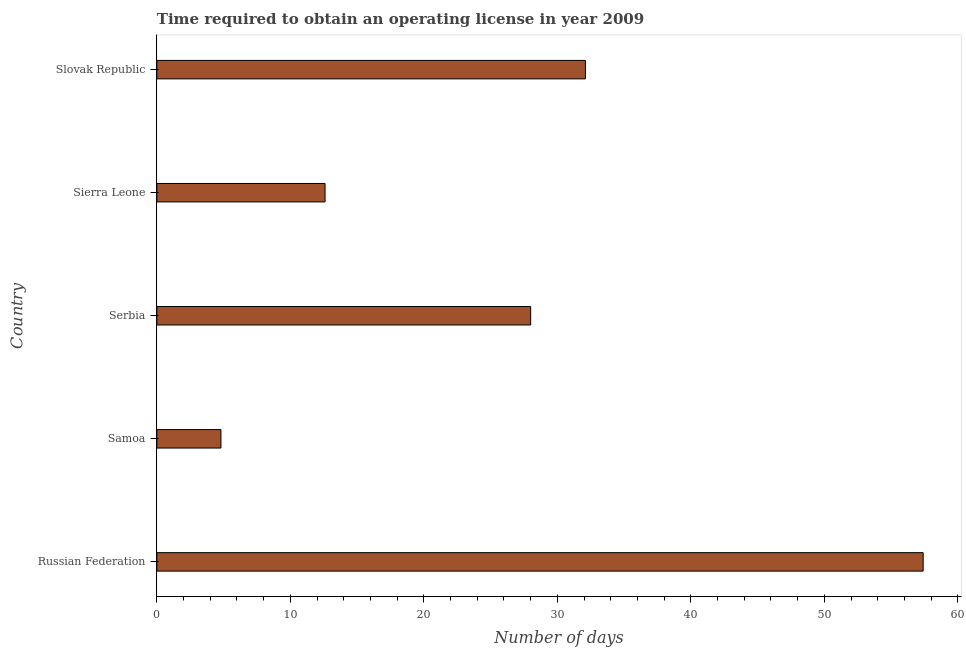Does the graph contain any zero values?
Keep it short and to the point. No. What is the title of the graph?
Keep it short and to the point. Time required to obtain an operating license in year 2009. What is the label or title of the X-axis?
Offer a terse response. Number of days. What is the label or title of the Y-axis?
Ensure brevity in your answer.  Country. What is the number of days to obtain operating license in Russian Federation?
Give a very brief answer. 57.4. Across all countries, what is the maximum number of days to obtain operating license?
Ensure brevity in your answer.  57.4. In which country was the number of days to obtain operating license maximum?
Offer a terse response. Russian Federation. In which country was the number of days to obtain operating license minimum?
Provide a succinct answer. Samoa. What is the sum of the number of days to obtain operating license?
Make the answer very short. 134.9. What is the difference between the number of days to obtain operating license in Samoa and Slovak Republic?
Offer a terse response. -27.3. What is the average number of days to obtain operating license per country?
Ensure brevity in your answer.  26.98. What is the median number of days to obtain operating license?
Offer a terse response. 28. In how many countries, is the number of days to obtain operating license greater than 48 days?
Your response must be concise. 1. What is the ratio of the number of days to obtain operating license in Serbia to that in Slovak Republic?
Keep it short and to the point. 0.87. Is the number of days to obtain operating license in Samoa less than that in Slovak Republic?
Ensure brevity in your answer.  Yes. Is the difference between the number of days to obtain operating license in Russian Federation and Sierra Leone greater than the difference between any two countries?
Offer a terse response. No. What is the difference between the highest and the second highest number of days to obtain operating license?
Ensure brevity in your answer.  25.3. What is the difference between the highest and the lowest number of days to obtain operating license?
Offer a terse response. 52.6. How many bars are there?
Provide a short and direct response. 5. Are all the bars in the graph horizontal?
Provide a succinct answer. Yes. What is the Number of days of Russian Federation?
Your answer should be very brief. 57.4. What is the Number of days in Sierra Leone?
Ensure brevity in your answer.  12.6. What is the Number of days in Slovak Republic?
Offer a terse response. 32.1. What is the difference between the Number of days in Russian Federation and Samoa?
Offer a very short reply. 52.6. What is the difference between the Number of days in Russian Federation and Serbia?
Provide a short and direct response. 29.4. What is the difference between the Number of days in Russian Federation and Sierra Leone?
Your answer should be compact. 44.8. What is the difference between the Number of days in Russian Federation and Slovak Republic?
Your answer should be compact. 25.3. What is the difference between the Number of days in Samoa and Serbia?
Your response must be concise. -23.2. What is the difference between the Number of days in Samoa and Slovak Republic?
Offer a very short reply. -27.3. What is the difference between the Number of days in Serbia and Slovak Republic?
Ensure brevity in your answer.  -4.1. What is the difference between the Number of days in Sierra Leone and Slovak Republic?
Keep it short and to the point. -19.5. What is the ratio of the Number of days in Russian Federation to that in Samoa?
Your answer should be very brief. 11.96. What is the ratio of the Number of days in Russian Federation to that in Serbia?
Provide a succinct answer. 2.05. What is the ratio of the Number of days in Russian Federation to that in Sierra Leone?
Give a very brief answer. 4.56. What is the ratio of the Number of days in Russian Federation to that in Slovak Republic?
Your answer should be very brief. 1.79. What is the ratio of the Number of days in Samoa to that in Serbia?
Make the answer very short. 0.17. What is the ratio of the Number of days in Samoa to that in Sierra Leone?
Offer a very short reply. 0.38. What is the ratio of the Number of days in Serbia to that in Sierra Leone?
Offer a terse response. 2.22. What is the ratio of the Number of days in Serbia to that in Slovak Republic?
Provide a succinct answer. 0.87. What is the ratio of the Number of days in Sierra Leone to that in Slovak Republic?
Offer a terse response. 0.39. 